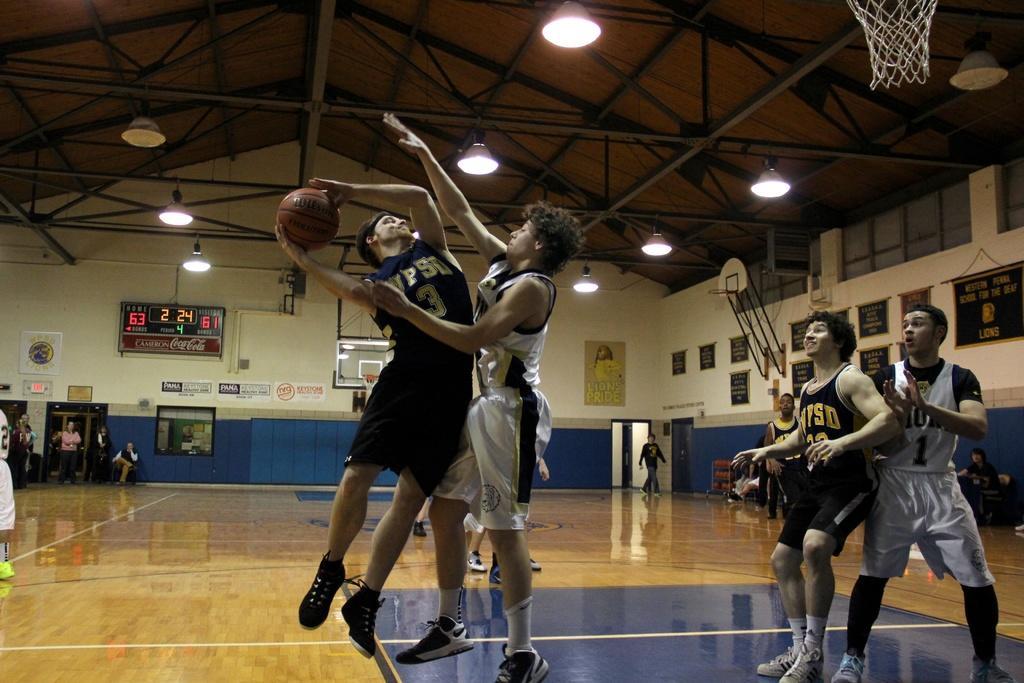Can you describe this image briefly? In the picture I can see people are standing on the floor among them the person on the left side is holding a ball in hands. In the background I can see wall which has boards and some other objects attached to it. I can also see some other objects on the floor. 